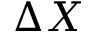<formula> <loc_0><loc_0><loc_500><loc_500>\Delta X</formula> 